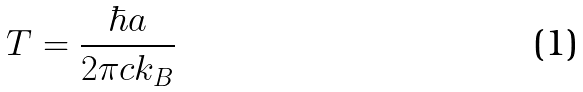<formula> <loc_0><loc_0><loc_500><loc_500>T = { \frac { \hbar { a } } { 2 \pi c k _ { B } } }</formula> 